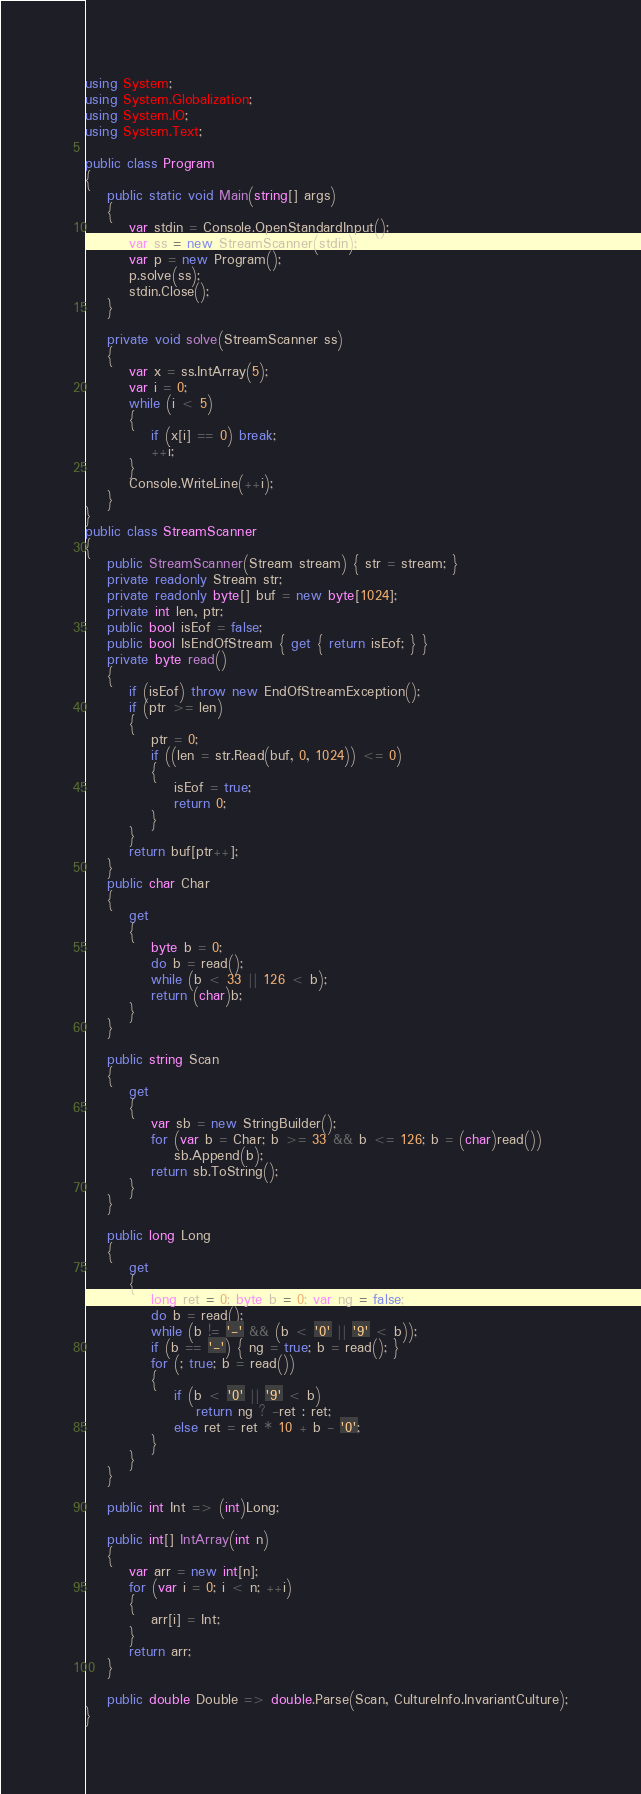Convert code to text. <code><loc_0><loc_0><loc_500><loc_500><_C#_>using System;
using System.Globalization;
using System.IO;
using System.Text;

public class Program
{
    public static void Main(string[] args)
    {
        var stdin = Console.OpenStandardInput();
        var ss = new StreamScanner(stdin);
        var p = new Program();
        p.solve(ss);
        stdin.Close();
    }

    private void solve(StreamScanner ss)
    {
        var x = ss.IntArray(5);
        var i = 0;
        while (i < 5)
        {
            if (x[i] == 0) break;
            ++i;
        }
        Console.WriteLine(++i);
    }
}
public class StreamScanner
{
    public StreamScanner(Stream stream) { str = stream; }
    private readonly Stream str;
    private readonly byte[] buf = new byte[1024];
    private int len, ptr;
    public bool isEof = false;
    public bool IsEndOfStream { get { return isEof; } }
    private byte read()
    {
        if (isEof) throw new EndOfStreamException();
        if (ptr >= len)
        {
            ptr = 0;
            if ((len = str.Read(buf, 0, 1024)) <= 0)
            {
                isEof = true;
                return 0;
            }
        }
        return buf[ptr++];
    }
    public char Char
    {
        get
        {
            byte b = 0;
            do b = read();
            while (b < 33 || 126 < b);
            return (char)b;
        }
    }

    public string Scan
    {
        get
        {
            var sb = new StringBuilder();
            for (var b = Char; b >= 33 && b <= 126; b = (char)read())
                sb.Append(b);
            return sb.ToString();
        }
    }

    public long Long
    {
        get
        {
            long ret = 0; byte b = 0; var ng = false;
            do b = read();
            while (b != '-' && (b < '0' || '9' < b));
            if (b == '-') { ng = true; b = read(); }
            for (; true; b = read())
            {
                if (b < '0' || '9' < b)
                    return ng ? -ret : ret;
                else ret = ret * 10 + b - '0';
            }
        }
    }

    public int Int => (int)Long;

    public int[] IntArray(int n)
    {
        var arr = new int[n];
        for (var i = 0; i < n; ++i)
        {
            arr[i] = Int;
        }
        return arr;
    }

    public double Double => double.Parse(Scan, CultureInfo.InvariantCulture);
}
</code> 